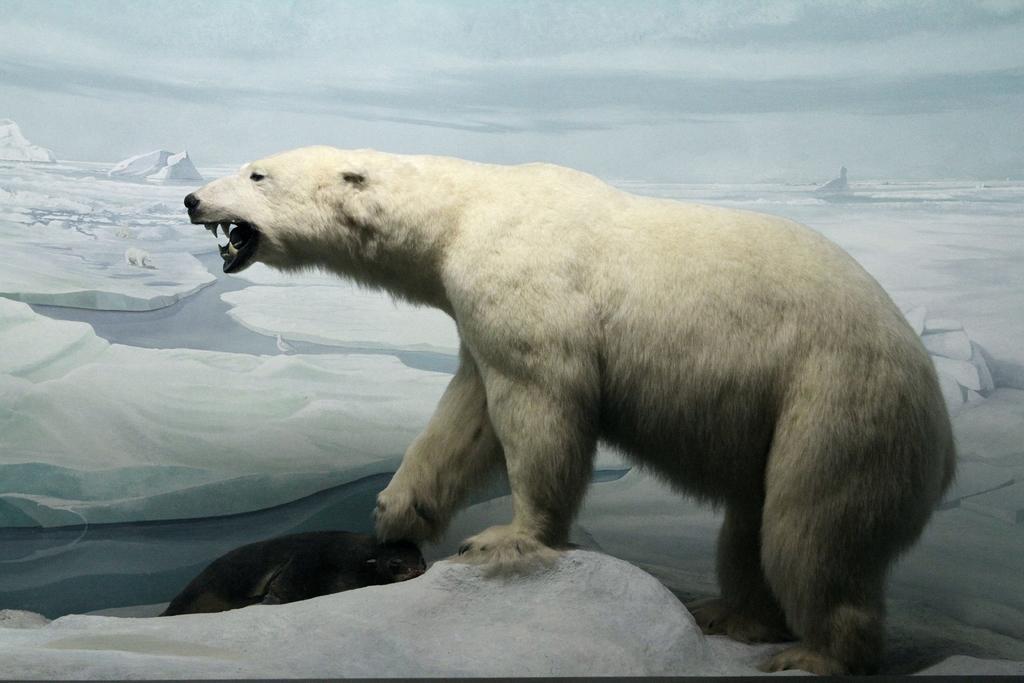Could you give a brief overview of what you see in this image? In this image we can see a polar bear and a seal on the iceberg. In the background there are icebergs, water and sky. 